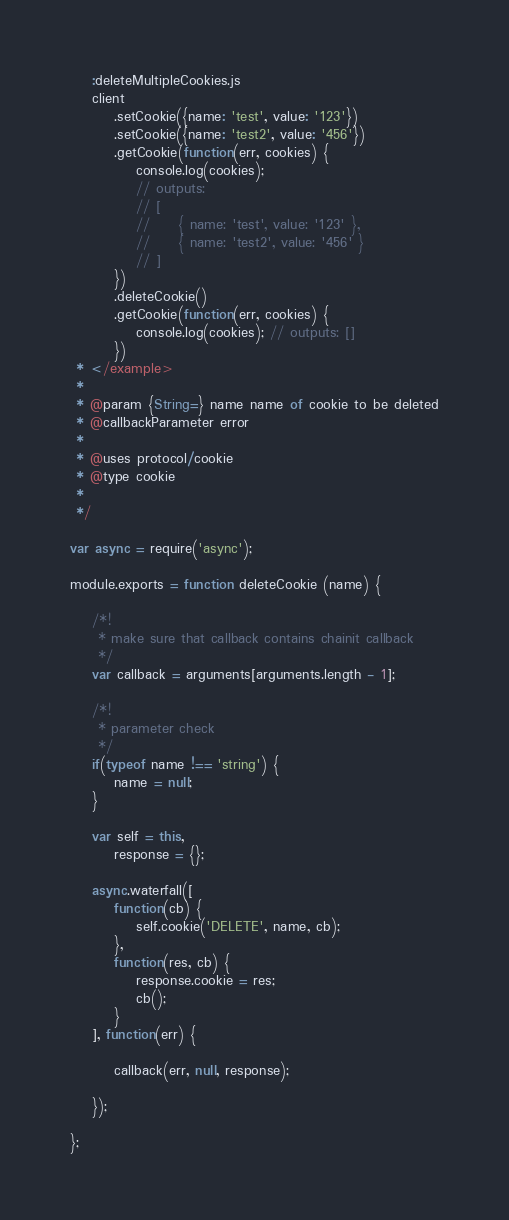Convert code to text. <code><loc_0><loc_0><loc_500><loc_500><_JavaScript_>
    :deleteMultipleCookies.js
    client
        .setCookie({name: 'test', value: '123'})
        .setCookie({name: 'test2', value: '456'})
        .getCookie(function(err, cookies) {
            console.log(cookies);
            // outputs:
            // [
            //     { name: 'test', value: '123' },
            //     { name: 'test2', value: '456' }
            // ]
        })
        .deleteCookie()
        .getCookie(function(err, cookies) {
            console.log(cookies); // outputs: []
        })
 * </example>
 *
 * @param {String=} name name of cookie to be deleted
 * @callbackParameter error
 *
 * @uses protocol/cookie
 * @type cookie
 *
 */

var async = require('async');

module.exports = function deleteCookie (name) {

    /*!
     * make sure that callback contains chainit callback
     */
    var callback = arguments[arguments.length - 1];

    /*!
     * parameter check
     */
    if(typeof name !== 'string') {
        name = null;
    }

    var self = this,
        response = {};

    async.waterfall([
        function(cb) {
            self.cookie('DELETE', name, cb);
        },
        function(res, cb) {
            response.cookie = res;
            cb();
        }
    ], function(err) {

        callback(err, null, response);

    });

};</code> 